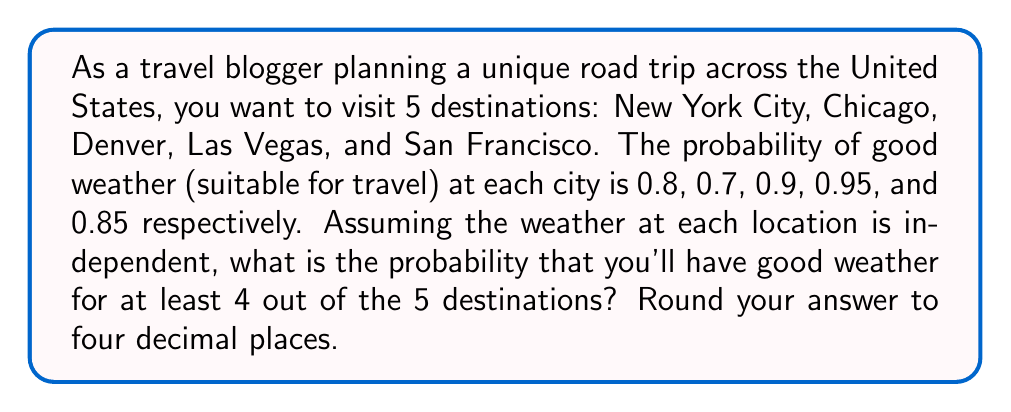Help me with this question. To solve this problem, we'll use the binomial probability distribution and the concept of complementary events.

Step 1: Define the probability of success (good weather) for each city.
$p(\text{NYC}) = 0.8$
$p(\text{Chicago}) = 0.7$
$p(\text{Denver}) = 0.9$
$p(\text{Las Vegas}) = 0.95$
$p(\text{San Francisco}) = 0.85$

Step 2: Calculate the average probability of good weather.
$$p = \frac{0.8 + 0.7 + 0.9 + 0.95 + 0.85}{5} = 0.84$$

Step 3: Use the binomial probability formula to calculate the probability of exactly 4 successes and exactly 5 successes.

For 4 successes:
$$P(X=4) = \binom{5}{4} \cdot 0.84^4 \cdot (1-0.84)^1 = 5 \cdot 0.84^4 \cdot 0.16 = 0.3369$$

For 5 successes:
$$P(X=5) = \binom{5}{5} \cdot 0.84^5 \cdot (1-0.84)^0 = 0.84^5 = 0.4182$$

Step 4: Sum the probabilities of 4 and 5 successes to get the probability of at least 4 successes.
$$P(X \geq 4) = P(X=4) + P(X=5) = 0.3369 + 0.4182 = 0.7551$$

Step 5: Round the result to four decimal places.
$$P(X \geq 4) \approx 0.7551$$
Answer: 0.7551 